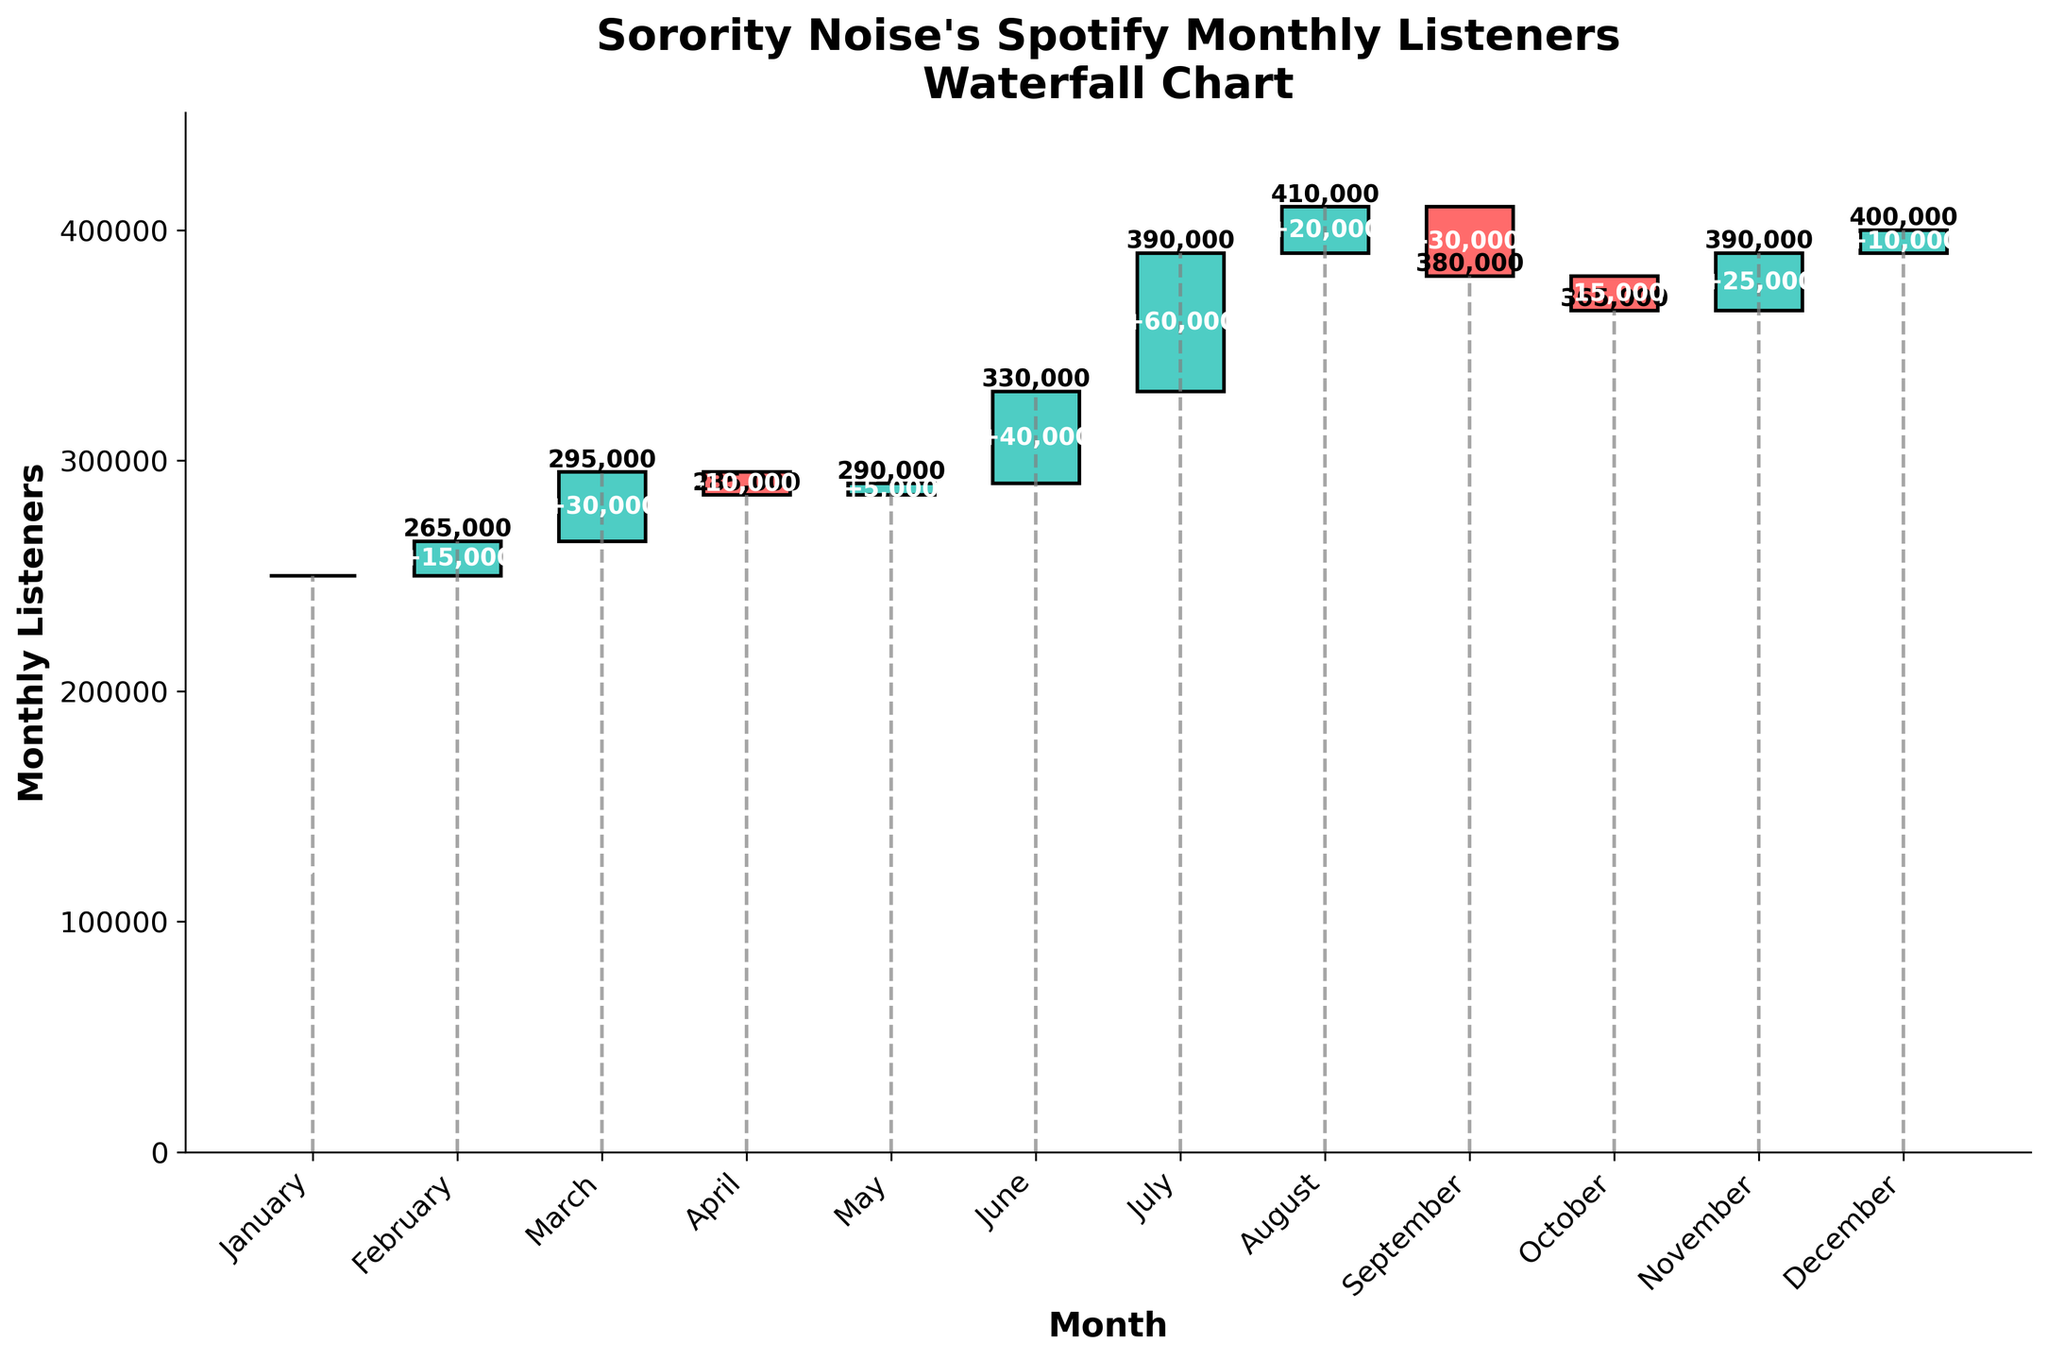Which month experienced the highest increase in monthly listeners? By observing the changes in monthly listeners for each month, July showed the highest increase, marked by a 60,000 gain.
Answer: July Which month had the lowest number of monthly listeners? From the bottom values of the bars, January had the lowest number of monthly listeners, starting at 250,000.
Answer: January What is the total change in monthly listeners from June to August? The changes for June, July, and August are 40,000, 60,000, and 20,000 respectively. Adding them up: 40,000 + 60,000 + 20,000 = 120,000.
Answer: 120,000 How many months had a decrease in monthly listeners? By counting months with negative changes in the plot: April (-10,000), September (-30,000), and October (-15,000), we find 3 months.
Answer: 3 What is the combined listener growth for the first quarter (January to March)? Changes for January, February, and March are 0, 15,000, and 30,000 respectively. Summing them gives: 0 + 15,000 + 30,000 = 45,000.
Answer: 45,000 Which two consecutive months have the largest difference in monthly listeners? Comparing differences between consecutive months, from July to August has the largest difference (410,000 - 390,000 = 20,000).
Answer: July to August How does the total number of monthly listeners in December compare to November? November has 390,000 listeners, and December has 400,000. The difference is: 400,000 - 390,000 = 10,000 more listeners in December.
Answer: December has 10,000 more What was the overall trend in monthly listeners over the year? Summing all the monthly changes results in a total increase, meaning the overall trend was upwards.
Answer: Upwards trend By how much did the monthly listeners change from the start to the end of the year? The listeners increased from 250,000 in January to 400,000 in December. The change is: 400,000 - 250,000 = 150,000.
Answer: 150,000 Which month experienced a notable recovery in listeners after a decrease? After a decrease in September (-30,000), October saw a recovery with an increase of 25,000 listeners in November.
Answer: November 